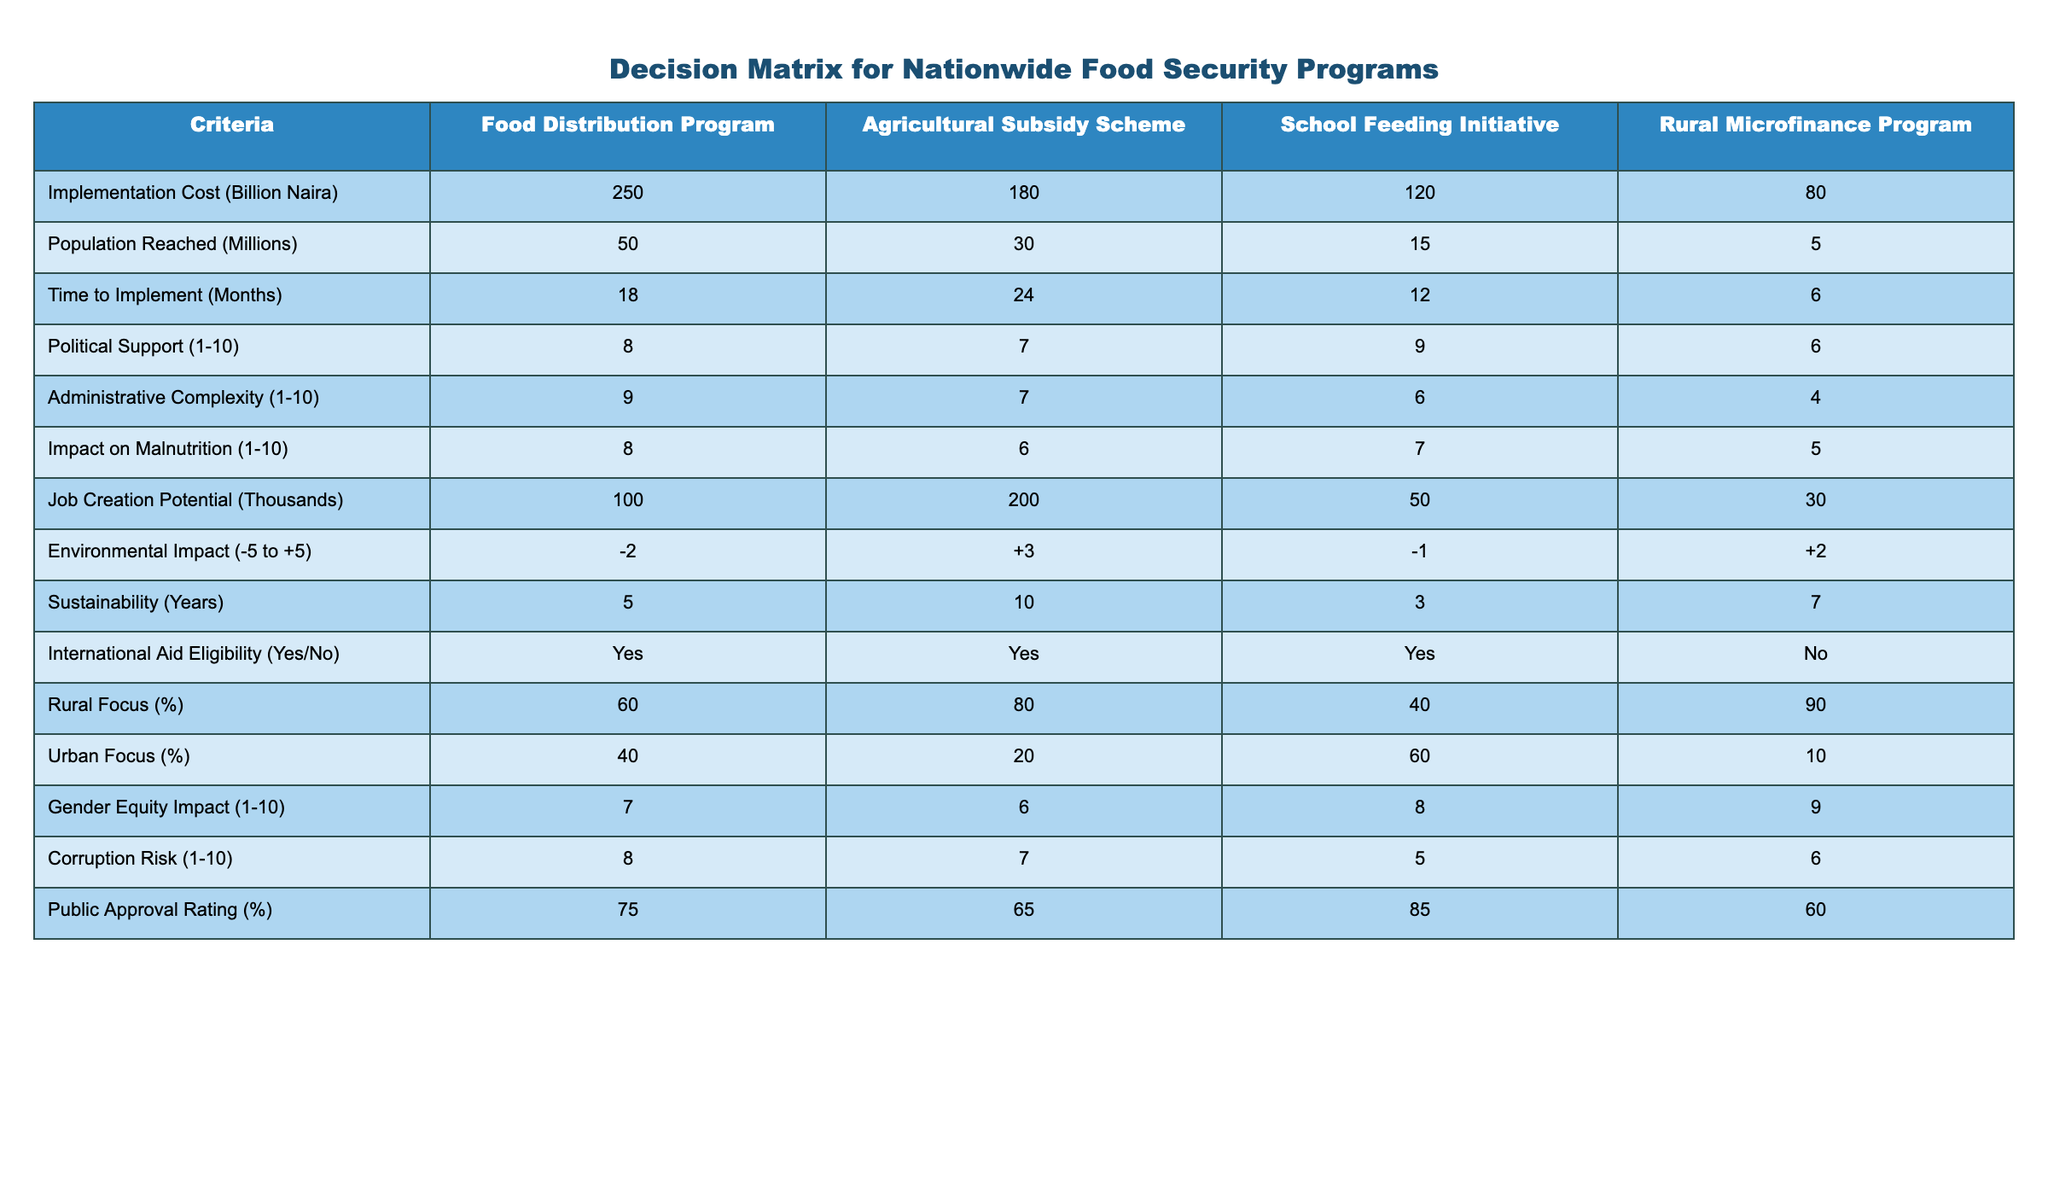What is the implementation cost of the Agricultural Subsidy Scheme? The table states the implementation cost for the Agricultural Subsidy Scheme as 180 billion Naira.
Answer: 180 billion Naira Which program reaches the largest population? By reviewing the "Population Reached (Millions)" column, the Food Distribution Program reaches 50 million, which is the highest compared to other programs.
Answer: Food Distribution Program What is the time to implement the School Feeding Initiative? The table lists the time to implement the School Feeding Initiative as 12 months.
Answer: 12 months Is the Rural Microfinance Program eligible for international aid? According to the "International Aid Eligibility" column, the Rural Microfinance Program is marked as 'No', indicating that it is not eligible for international aid.
Answer: No What is the difference in job creation potential between the Agricultural Subsidy Scheme and the School Feeding Initiative? The Agricultural Subsidy Scheme has a job creation potential of 200,000, while the School Feeding Initiative has 50,000. The difference is 200,000 - 50,000 = 150,000.
Answer: 150,000 Which program has the highest political support score, and what is that score? Checking the "Political Support (1-10)" column, we see the School Feeding Initiative has the highest score of 9.
Answer: School Feeding Initiative, 9 What is the average sustainability in years for all four programs? The sustainabilities are 5, 10, 3, and 7 years. We sum these values: 5 + 10 + 3 + 7 = 25. Dividing by 4 gives an average of 25/4 = 6.25 years.
Answer: 6.25 years Which program has the lowest rural focus percentage? Reviewing the "Rural Focus (%)" column, the School Feeding Initiative has the lowest rural focus percentage of 40%.
Answer: 40% How does the environmental impact of the Agricultural Subsidy Scheme compare with the others? The Agricultural Subsidy Scheme has an environmental impact score of +3, which is the highest compared to others, indicating it is the most environmentally friendly.
Answer: +3, highest 